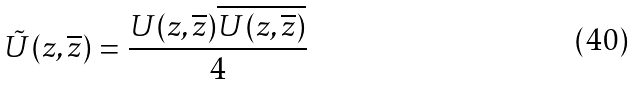<formula> <loc_0><loc_0><loc_500><loc_500>\tilde { U } ( z , \overline { z } ) = \frac { U ( z , \overline { z } ) \overline { U ( z , \overline { z } ) } } { 4 }</formula> 